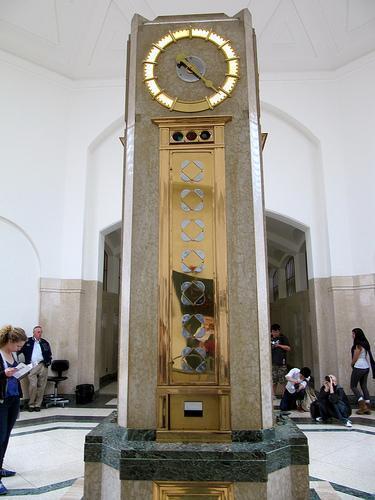How many people are in the picture?
Give a very brief answer. 6. How many chairs are in the picture?
Give a very brief answer. 1. 